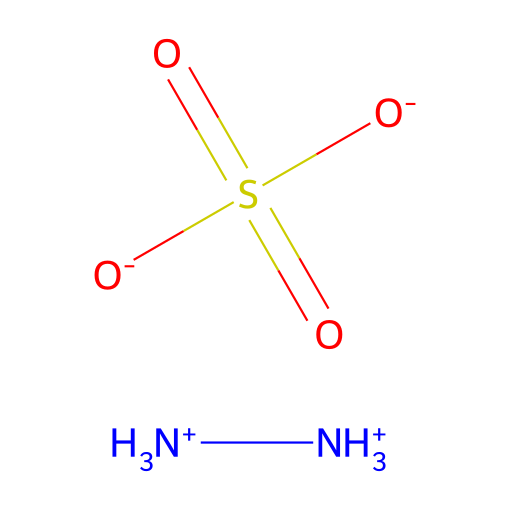What is the molecular formula of hydrazine sulfate? The SMILES representation indicates that it contains two nitrogen atoms (NH3+), one sulfur atom (S), and four oxygen atoms (O) from the sulfate group (O-), so the molecular formula can be derived as N2H8O4S.
Answer: N2H8O4S How many oxygen atoms are present in hydrazine sulfate? Analyzing the sulfate group part of the SMILES, we see that there are four oxygen atoms attached to the sulfur in the structure.
Answer: four What type of chemical is hydrazine sulfate categorized as? Hydrazine sulfate is categorized as a hydrazine, which is evident from the presence of the nitrogen atoms (NH3+) in the structure suggesting its classification as a member of the hydrazine family.
Answer: hydrazine What is the charge of the hydrazine component in hydrazine sulfate? Looking at the structure, both nitrogen atoms are shown as positively charged in the SMILES representation ([NH3+]), indicating that the hydrazine component carries a positive charge.
Answer: positive How does hydrazine sulfate act as a reducing agent? The structure of hydrazine sulfate shows nitrogen atoms that can donate electrons due to their positive charge, allowing them to reduce metal ions in plating processes.
Answer: electron donor What role does the sulfate group play in hydrazine sulfate's properties? The sulfate group (O-)(S(=O)(=O)[O-]) contributes to the solubility and stability of hydrazine sulfate in solution, significantly affecting its reactivity as a reducing agent during metal plating.
Answer: solubility and stability What is the oxidation state of sulfur in hydrazine sulfate? In the sulfate group, sulfur is bonded to four oxygen atoms in which the oxidation state can be determined as +6, since each double-bonded oxygen counts as -2 and the remaining oxygens as -1 each.
Answer: +6 